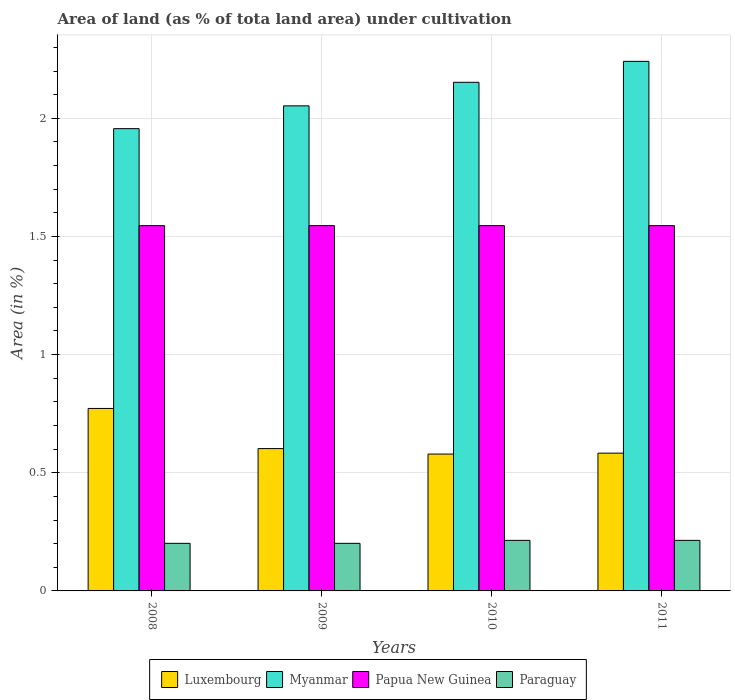How many different coloured bars are there?
Give a very brief answer. 4. How many groups of bars are there?
Your answer should be compact. 4. Are the number of bars on each tick of the X-axis equal?
Keep it short and to the point. Yes. How many bars are there on the 4th tick from the right?
Make the answer very short. 4. In how many cases, is the number of bars for a given year not equal to the number of legend labels?
Your answer should be very brief. 0. What is the percentage of land under cultivation in Paraguay in 2010?
Offer a very short reply. 0.21. Across all years, what is the maximum percentage of land under cultivation in Paraguay?
Make the answer very short. 0.21. Across all years, what is the minimum percentage of land under cultivation in Luxembourg?
Your answer should be very brief. 0.58. In which year was the percentage of land under cultivation in Papua New Guinea maximum?
Ensure brevity in your answer.  2008. What is the total percentage of land under cultivation in Myanmar in the graph?
Your answer should be very brief. 8.4. What is the difference between the percentage of land under cultivation in Papua New Guinea in 2009 and that in 2011?
Provide a succinct answer. 0. What is the difference between the percentage of land under cultivation in Myanmar in 2011 and the percentage of land under cultivation in Papua New Guinea in 2009?
Your answer should be compact. 0.7. What is the average percentage of land under cultivation in Myanmar per year?
Your response must be concise. 2.1. In the year 2011, what is the difference between the percentage of land under cultivation in Myanmar and percentage of land under cultivation in Papua New Guinea?
Your answer should be compact. 0.7. In how many years, is the percentage of land under cultivation in Papua New Guinea greater than 0.1 %?
Make the answer very short. 4. What is the ratio of the percentage of land under cultivation in Luxembourg in 2010 to that in 2011?
Provide a succinct answer. 0.99. What is the difference between the highest and the second highest percentage of land under cultivation in Papua New Guinea?
Give a very brief answer. 0. Is the sum of the percentage of land under cultivation in Myanmar in 2008 and 2011 greater than the maximum percentage of land under cultivation in Papua New Guinea across all years?
Make the answer very short. Yes. Is it the case that in every year, the sum of the percentage of land under cultivation in Myanmar and percentage of land under cultivation in Papua New Guinea is greater than the sum of percentage of land under cultivation in Paraguay and percentage of land under cultivation in Luxembourg?
Provide a succinct answer. Yes. What does the 3rd bar from the left in 2008 represents?
Your response must be concise. Papua New Guinea. What does the 3rd bar from the right in 2009 represents?
Your answer should be compact. Myanmar. Is it the case that in every year, the sum of the percentage of land under cultivation in Papua New Guinea and percentage of land under cultivation in Luxembourg is greater than the percentage of land under cultivation in Myanmar?
Give a very brief answer. No. What is the difference between two consecutive major ticks on the Y-axis?
Offer a very short reply. 0.5. Are the values on the major ticks of Y-axis written in scientific E-notation?
Offer a very short reply. No. Does the graph contain any zero values?
Give a very brief answer. No. How many legend labels are there?
Offer a very short reply. 4. What is the title of the graph?
Your response must be concise. Area of land (as % of tota land area) under cultivation. Does "Korea (Democratic)" appear as one of the legend labels in the graph?
Your response must be concise. No. What is the label or title of the Y-axis?
Your answer should be compact. Area (in %). What is the Area (in %) in Luxembourg in 2008?
Your answer should be compact. 0.77. What is the Area (in %) of Myanmar in 2008?
Your answer should be very brief. 1.96. What is the Area (in %) in Papua New Guinea in 2008?
Provide a short and direct response. 1.55. What is the Area (in %) in Paraguay in 2008?
Provide a succinct answer. 0.2. What is the Area (in %) in Luxembourg in 2009?
Provide a succinct answer. 0.6. What is the Area (in %) of Myanmar in 2009?
Provide a short and direct response. 2.05. What is the Area (in %) in Papua New Guinea in 2009?
Offer a terse response. 1.55. What is the Area (in %) of Paraguay in 2009?
Ensure brevity in your answer.  0.2. What is the Area (in %) of Luxembourg in 2010?
Provide a succinct answer. 0.58. What is the Area (in %) of Myanmar in 2010?
Ensure brevity in your answer.  2.15. What is the Area (in %) of Papua New Guinea in 2010?
Provide a short and direct response. 1.55. What is the Area (in %) of Paraguay in 2010?
Ensure brevity in your answer.  0.21. What is the Area (in %) in Luxembourg in 2011?
Provide a short and direct response. 0.58. What is the Area (in %) in Myanmar in 2011?
Provide a succinct answer. 2.24. What is the Area (in %) in Papua New Guinea in 2011?
Give a very brief answer. 1.55. What is the Area (in %) in Paraguay in 2011?
Offer a very short reply. 0.21. Across all years, what is the maximum Area (in %) in Luxembourg?
Ensure brevity in your answer.  0.77. Across all years, what is the maximum Area (in %) in Myanmar?
Ensure brevity in your answer.  2.24. Across all years, what is the maximum Area (in %) in Papua New Guinea?
Offer a terse response. 1.55. Across all years, what is the maximum Area (in %) of Paraguay?
Your response must be concise. 0.21. Across all years, what is the minimum Area (in %) in Luxembourg?
Provide a short and direct response. 0.58. Across all years, what is the minimum Area (in %) of Myanmar?
Your answer should be very brief. 1.96. Across all years, what is the minimum Area (in %) of Papua New Guinea?
Your answer should be very brief. 1.55. Across all years, what is the minimum Area (in %) in Paraguay?
Your answer should be compact. 0.2. What is the total Area (in %) in Luxembourg in the graph?
Keep it short and to the point. 2.54. What is the total Area (in %) of Myanmar in the graph?
Provide a succinct answer. 8.4. What is the total Area (in %) of Papua New Guinea in the graph?
Offer a terse response. 6.18. What is the total Area (in %) of Paraguay in the graph?
Keep it short and to the point. 0.83. What is the difference between the Area (in %) in Luxembourg in 2008 and that in 2009?
Keep it short and to the point. 0.17. What is the difference between the Area (in %) of Myanmar in 2008 and that in 2009?
Your answer should be very brief. -0.1. What is the difference between the Area (in %) of Paraguay in 2008 and that in 2009?
Ensure brevity in your answer.  0. What is the difference between the Area (in %) in Luxembourg in 2008 and that in 2010?
Provide a succinct answer. 0.19. What is the difference between the Area (in %) of Myanmar in 2008 and that in 2010?
Your response must be concise. -0.2. What is the difference between the Area (in %) of Paraguay in 2008 and that in 2010?
Provide a succinct answer. -0.01. What is the difference between the Area (in %) in Luxembourg in 2008 and that in 2011?
Provide a short and direct response. 0.19. What is the difference between the Area (in %) in Myanmar in 2008 and that in 2011?
Provide a short and direct response. -0.28. What is the difference between the Area (in %) of Papua New Guinea in 2008 and that in 2011?
Give a very brief answer. 0. What is the difference between the Area (in %) of Paraguay in 2008 and that in 2011?
Your answer should be compact. -0.01. What is the difference between the Area (in %) of Luxembourg in 2009 and that in 2010?
Your answer should be very brief. 0.02. What is the difference between the Area (in %) of Myanmar in 2009 and that in 2010?
Your answer should be compact. -0.1. What is the difference between the Area (in %) in Papua New Guinea in 2009 and that in 2010?
Ensure brevity in your answer.  0. What is the difference between the Area (in %) in Paraguay in 2009 and that in 2010?
Offer a terse response. -0.01. What is the difference between the Area (in %) of Luxembourg in 2009 and that in 2011?
Make the answer very short. 0.02. What is the difference between the Area (in %) in Myanmar in 2009 and that in 2011?
Give a very brief answer. -0.19. What is the difference between the Area (in %) in Papua New Guinea in 2009 and that in 2011?
Your answer should be very brief. 0. What is the difference between the Area (in %) of Paraguay in 2009 and that in 2011?
Your answer should be compact. -0.01. What is the difference between the Area (in %) in Luxembourg in 2010 and that in 2011?
Make the answer very short. -0. What is the difference between the Area (in %) in Myanmar in 2010 and that in 2011?
Your response must be concise. -0.09. What is the difference between the Area (in %) of Papua New Guinea in 2010 and that in 2011?
Your response must be concise. 0. What is the difference between the Area (in %) of Paraguay in 2010 and that in 2011?
Keep it short and to the point. 0. What is the difference between the Area (in %) of Luxembourg in 2008 and the Area (in %) of Myanmar in 2009?
Ensure brevity in your answer.  -1.28. What is the difference between the Area (in %) in Luxembourg in 2008 and the Area (in %) in Papua New Guinea in 2009?
Make the answer very short. -0.77. What is the difference between the Area (in %) of Luxembourg in 2008 and the Area (in %) of Paraguay in 2009?
Your answer should be very brief. 0.57. What is the difference between the Area (in %) in Myanmar in 2008 and the Area (in %) in Papua New Guinea in 2009?
Offer a very short reply. 0.41. What is the difference between the Area (in %) in Myanmar in 2008 and the Area (in %) in Paraguay in 2009?
Ensure brevity in your answer.  1.75. What is the difference between the Area (in %) of Papua New Guinea in 2008 and the Area (in %) of Paraguay in 2009?
Offer a very short reply. 1.34. What is the difference between the Area (in %) in Luxembourg in 2008 and the Area (in %) in Myanmar in 2010?
Provide a short and direct response. -1.38. What is the difference between the Area (in %) of Luxembourg in 2008 and the Area (in %) of Papua New Guinea in 2010?
Give a very brief answer. -0.77. What is the difference between the Area (in %) in Luxembourg in 2008 and the Area (in %) in Paraguay in 2010?
Offer a terse response. 0.56. What is the difference between the Area (in %) in Myanmar in 2008 and the Area (in %) in Papua New Guinea in 2010?
Provide a succinct answer. 0.41. What is the difference between the Area (in %) in Myanmar in 2008 and the Area (in %) in Paraguay in 2010?
Make the answer very short. 1.74. What is the difference between the Area (in %) in Papua New Guinea in 2008 and the Area (in %) in Paraguay in 2010?
Your answer should be compact. 1.33. What is the difference between the Area (in %) in Luxembourg in 2008 and the Area (in %) in Myanmar in 2011?
Ensure brevity in your answer.  -1.47. What is the difference between the Area (in %) in Luxembourg in 2008 and the Area (in %) in Papua New Guinea in 2011?
Offer a terse response. -0.77. What is the difference between the Area (in %) in Luxembourg in 2008 and the Area (in %) in Paraguay in 2011?
Provide a succinct answer. 0.56. What is the difference between the Area (in %) of Myanmar in 2008 and the Area (in %) of Papua New Guinea in 2011?
Provide a succinct answer. 0.41. What is the difference between the Area (in %) of Myanmar in 2008 and the Area (in %) of Paraguay in 2011?
Your response must be concise. 1.74. What is the difference between the Area (in %) of Papua New Guinea in 2008 and the Area (in %) of Paraguay in 2011?
Keep it short and to the point. 1.33. What is the difference between the Area (in %) in Luxembourg in 2009 and the Area (in %) in Myanmar in 2010?
Your answer should be compact. -1.55. What is the difference between the Area (in %) of Luxembourg in 2009 and the Area (in %) of Papua New Guinea in 2010?
Provide a short and direct response. -0.94. What is the difference between the Area (in %) in Luxembourg in 2009 and the Area (in %) in Paraguay in 2010?
Ensure brevity in your answer.  0.39. What is the difference between the Area (in %) in Myanmar in 2009 and the Area (in %) in Papua New Guinea in 2010?
Make the answer very short. 0.51. What is the difference between the Area (in %) of Myanmar in 2009 and the Area (in %) of Paraguay in 2010?
Make the answer very short. 1.84. What is the difference between the Area (in %) of Papua New Guinea in 2009 and the Area (in %) of Paraguay in 2010?
Make the answer very short. 1.33. What is the difference between the Area (in %) of Luxembourg in 2009 and the Area (in %) of Myanmar in 2011?
Your response must be concise. -1.64. What is the difference between the Area (in %) of Luxembourg in 2009 and the Area (in %) of Papua New Guinea in 2011?
Your answer should be compact. -0.94. What is the difference between the Area (in %) in Luxembourg in 2009 and the Area (in %) in Paraguay in 2011?
Offer a terse response. 0.39. What is the difference between the Area (in %) of Myanmar in 2009 and the Area (in %) of Papua New Guinea in 2011?
Offer a terse response. 0.51. What is the difference between the Area (in %) in Myanmar in 2009 and the Area (in %) in Paraguay in 2011?
Ensure brevity in your answer.  1.84. What is the difference between the Area (in %) of Papua New Guinea in 2009 and the Area (in %) of Paraguay in 2011?
Offer a terse response. 1.33. What is the difference between the Area (in %) in Luxembourg in 2010 and the Area (in %) in Myanmar in 2011?
Keep it short and to the point. -1.66. What is the difference between the Area (in %) in Luxembourg in 2010 and the Area (in %) in Papua New Guinea in 2011?
Your answer should be very brief. -0.97. What is the difference between the Area (in %) in Luxembourg in 2010 and the Area (in %) in Paraguay in 2011?
Your answer should be compact. 0.37. What is the difference between the Area (in %) in Myanmar in 2010 and the Area (in %) in Papua New Guinea in 2011?
Your response must be concise. 0.61. What is the difference between the Area (in %) of Myanmar in 2010 and the Area (in %) of Paraguay in 2011?
Provide a short and direct response. 1.94. What is the difference between the Area (in %) in Papua New Guinea in 2010 and the Area (in %) in Paraguay in 2011?
Provide a succinct answer. 1.33. What is the average Area (in %) in Luxembourg per year?
Make the answer very short. 0.63. What is the average Area (in %) of Myanmar per year?
Make the answer very short. 2.1. What is the average Area (in %) of Papua New Guinea per year?
Offer a very short reply. 1.55. What is the average Area (in %) of Paraguay per year?
Provide a succinct answer. 0.21. In the year 2008, what is the difference between the Area (in %) of Luxembourg and Area (in %) of Myanmar?
Provide a succinct answer. -1.18. In the year 2008, what is the difference between the Area (in %) of Luxembourg and Area (in %) of Papua New Guinea?
Offer a terse response. -0.77. In the year 2008, what is the difference between the Area (in %) in Luxembourg and Area (in %) in Paraguay?
Give a very brief answer. 0.57. In the year 2008, what is the difference between the Area (in %) of Myanmar and Area (in %) of Papua New Guinea?
Provide a short and direct response. 0.41. In the year 2008, what is the difference between the Area (in %) of Myanmar and Area (in %) of Paraguay?
Ensure brevity in your answer.  1.75. In the year 2008, what is the difference between the Area (in %) of Papua New Guinea and Area (in %) of Paraguay?
Your answer should be compact. 1.34. In the year 2009, what is the difference between the Area (in %) of Luxembourg and Area (in %) of Myanmar?
Provide a succinct answer. -1.45. In the year 2009, what is the difference between the Area (in %) of Luxembourg and Area (in %) of Papua New Guinea?
Your response must be concise. -0.94. In the year 2009, what is the difference between the Area (in %) in Luxembourg and Area (in %) in Paraguay?
Offer a terse response. 0.4. In the year 2009, what is the difference between the Area (in %) in Myanmar and Area (in %) in Papua New Guinea?
Provide a succinct answer. 0.51. In the year 2009, what is the difference between the Area (in %) of Myanmar and Area (in %) of Paraguay?
Provide a succinct answer. 1.85. In the year 2009, what is the difference between the Area (in %) in Papua New Guinea and Area (in %) in Paraguay?
Provide a succinct answer. 1.34. In the year 2010, what is the difference between the Area (in %) in Luxembourg and Area (in %) in Myanmar?
Your answer should be compact. -1.57. In the year 2010, what is the difference between the Area (in %) of Luxembourg and Area (in %) of Papua New Guinea?
Keep it short and to the point. -0.97. In the year 2010, what is the difference between the Area (in %) of Luxembourg and Area (in %) of Paraguay?
Your answer should be compact. 0.37. In the year 2010, what is the difference between the Area (in %) in Myanmar and Area (in %) in Papua New Guinea?
Keep it short and to the point. 0.61. In the year 2010, what is the difference between the Area (in %) in Myanmar and Area (in %) in Paraguay?
Provide a short and direct response. 1.94. In the year 2010, what is the difference between the Area (in %) of Papua New Guinea and Area (in %) of Paraguay?
Your response must be concise. 1.33. In the year 2011, what is the difference between the Area (in %) of Luxembourg and Area (in %) of Myanmar?
Give a very brief answer. -1.66. In the year 2011, what is the difference between the Area (in %) of Luxembourg and Area (in %) of Papua New Guinea?
Provide a short and direct response. -0.96. In the year 2011, what is the difference between the Area (in %) in Luxembourg and Area (in %) in Paraguay?
Your answer should be compact. 0.37. In the year 2011, what is the difference between the Area (in %) of Myanmar and Area (in %) of Papua New Guinea?
Your answer should be compact. 0.7. In the year 2011, what is the difference between the Area (in %) in Myanmar and Area (in %) in Paraguay?
Offer a very short reply. 2.03. In the year 2011, what is the difference between the Area (in %) in Papua New Guinea and Area (in %) in Paraguay?
Your answer should be very brief. 1.33. What is the ratio of the Area (in %) of Luxembourg in 2008 to that in 2009?
Give a very brief answer. 1.28. What is the ratio of the Area (in %) of Myanmar in 2008 to that in 2009?
Offer a terse response. 0.95. What is the ratio of the Area (in %) in Papua New Guinea in 2008 to that in 2009?
Your response must be concise. 1. What is the ratio of the Area (in %) of Myanmar in 2008 to that in 2010?
Make the answer very short. 0.91. What is the ratio of the Area (in %) of Papua New Guinea in 2008 to that in 2010?
Offer a very short reply. 1. What is the ratio of the Area (in %) of Paraguay in 2008 to that in 2010?
Offer a terse response. 0.94. What is the ratio of the Area (in %) in Luxembourg in 2008 to that in 2011?
Your answer should be compact. 1.32. What is the ratio of the Area (in %) of Myanmar in 2008 to that in 2011?
Provide a short and direct response. 0.87. What is the ratio of the Area (in %) of Papua New Guinea in 2008 to that in 2011?
Your answer should be compact. 1. What is the ratio of the Area (in %) in Paraguay in 2008 to that in 2011?
Provide a short and direct response. 0.94. What is the ratio of the Area (in %) in Myanmar in 2009 to that in 2010?
Offer a very short reply. 0.95. What is the ratio of the Area (in %) of Paraguay in 2009 to that in 2010?
Give a very brief answer. 0.94. What is the ratio of the Area (in %) in Luxembourg in 2009 to that in 2011?
Ensure brevity in your answer.  1.03. What is the ratio of the Area (in %) in Myanmar in 2009 to that in 2011?
Make the answer very short. 0.92. What is the ratio of the Area (in %) in Luxembourg in 2010 to that in 2011?
Give a very brief answer. 0.99. What is the ratio of the Area (in %) of Myanmar in 2010 to that in 2011?
Provide a succinct answer. 0.96. What is the difference between the highest and the second highest Area (in %) in Luxembourg?
Provide a succinct answer. 0.17. What is the difference between the highest and the second highest Area (in %) of Myanmar?
Provide a short and direct response. 0.09. What is the difference between the highest and the second highest Area (in %) of Paraguay?
Give a very brief answer. 0. What is the difference between the highest and the lowest Area (in %) of Luxembourg?
Offer a terse response. 0.19. What is the difference between the highest and the lowest Area (in %) of Myanmar?
Ensure brevity in your answer.  0.28. What is the difference between the highest and the lowest Area (in %) of Paraguay?
Your answer should be compact. 0.01. 